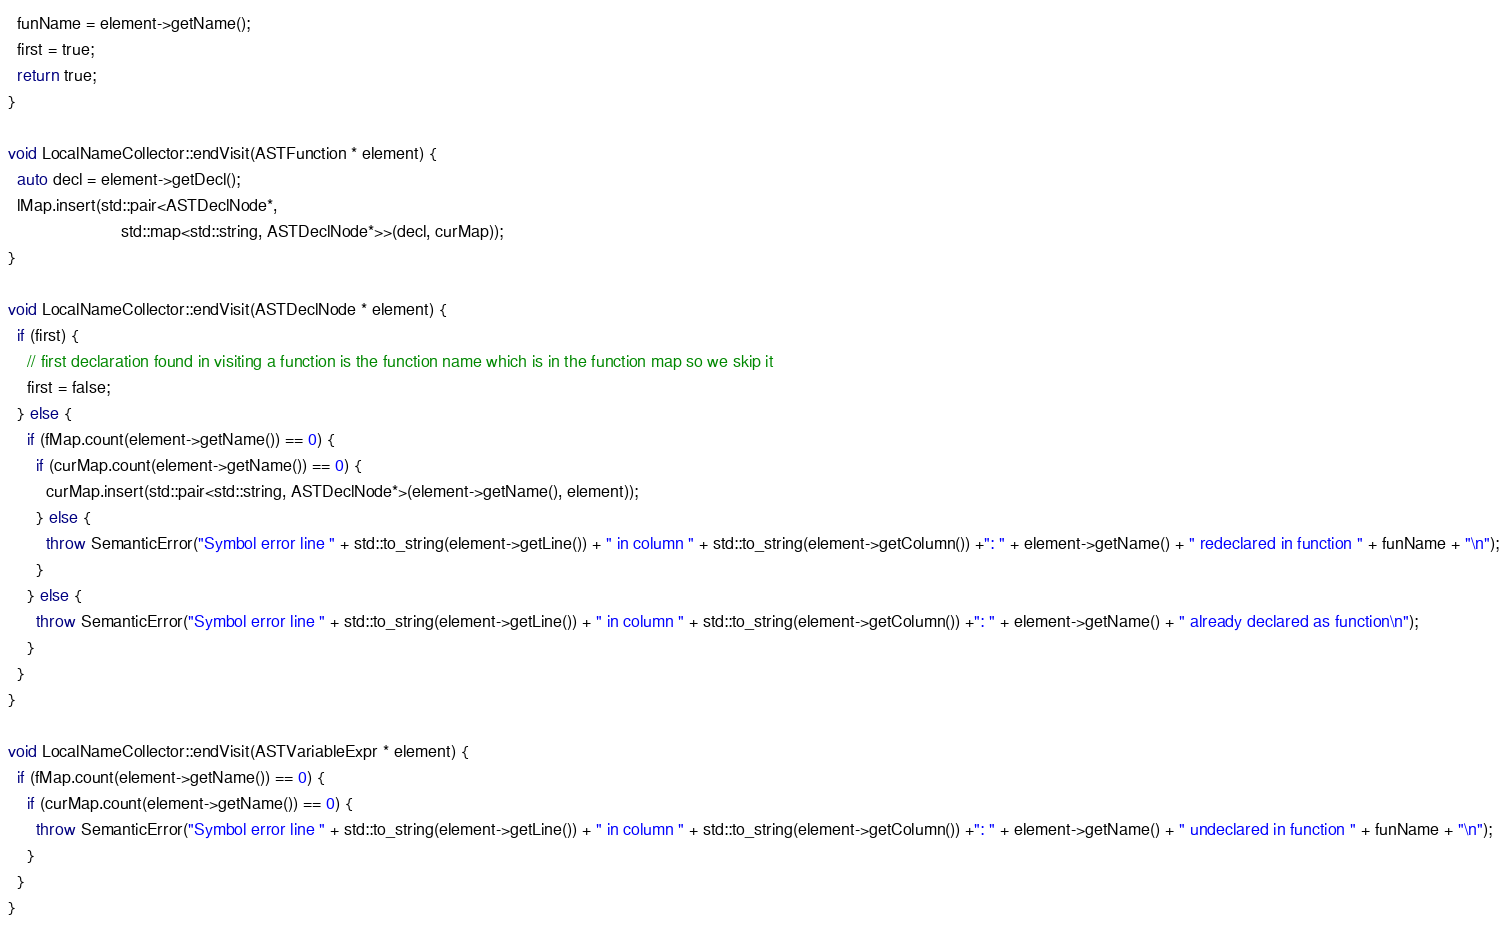<code> <loc_0><loc_0><loc_500><loc_500><_C++_>  funName = element->getName();
  first = true;
  return true;
}

void LocalNameCollector::endVisit(ASTFunction * element) {
  auto decl = element->getDecl();
  lMap.insert(std::pair<ASTDeclNode*,
                        std::map<std::string, ASTDeclNode*>>(decl, curMap));
}

void LocalNameCollector::endVisit(ASTDeclNode * element) {
  if (first) {
    // first declaration found in visiting a function is the function name which is in the function map so we skip it
    first = false;
  } else {
    if (fMap.count(element->getName()) == 0) {
      if (curMap.count(element->getName()) == 0) {
        curMap.insert(std::pair<std::string, ASTDeclNode*>(element->getName(), element));
      } else {
        throw SemanticError("Symbol error line " + std::to_string(element->getLine()) + " in column " + std::to_string(element->getColumn()) +": " + element->getName() + " redeclared in function " + funName + "\n");
      }
    } else {
      throw SemanticError("Symbol error line " + std::to_string(element->getLine()) + " in column " + std::to_string(element->getColumn()) +": " + element->getName() + " already declared as function\n");
    }
  }
}

void LocalNameCollector::endVisit(ASTVariableExpr * element) {
  if (fMap.count(element->getName()) == 0) {
    if (curMap.count(element->getName()) == 0) {
      throw SemanticError("Symbol error line " + std::to_string(element->getLine()) + " in column " + std::to_string(element->getColumn()) +": " + element->getName() + " undeclared in function " + funName + "\n");
    }
  }
}

</code> 